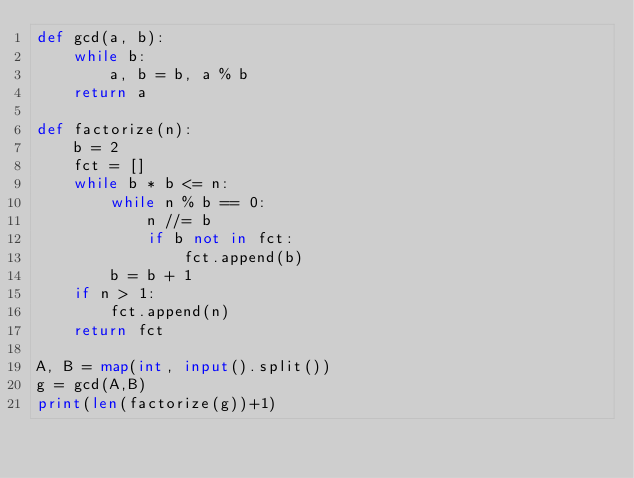Convert code to text. <code><loc_0><loc_0><loc_500><loc_500><_Python_>def gcd(a, b):
	while b:
		a, b = b, a % b
	return a

def factorize(n):
    b = 2
    fct = []
    while b * b <= n:
        while n % b == 0:
            n //= b
            if b not in fct:
                fct.append(b)
        b = b + 1
    if n > 1:
        fct.append(n)
    return fct

A, B = map(int, input().split())
g = gcd(A,B)
print(len(factorize(g))+1)</code> 